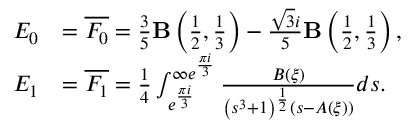Convert formula to latex. <formula><loc_0><loc_0><loc_500><loc_500>\begin{array} { r l } { E _ { 0 } } & { = \overline { { F _ { 0 } } } = \frac { 3 } { 5 } B \left ( \frac { 1 } { 2 } , \frac { 1 } { 3 } \right ) - \frac { \sqrt { 3 } i } { 5 } B \left ( \frac { 1 } { 2 } , \frac { 1 } { 3 } \right ) , } \\ { E _ { 1 } } & { = \overline { { F _ { 1 } } } = \frac { 1 } { 4 } \int _ { e ^ { \frac { \pi i } { 3 } } } ^ { \infty e ^ { \frac { \pi i } { 3 } } } \frac { B ( \xi ) } { \left ( s ^ { 3 } + 1 \right ) ^ { \frac { 1 } { 2 } } ( s - A ( \xi ) ) } d s . } \end{array}</formula> 